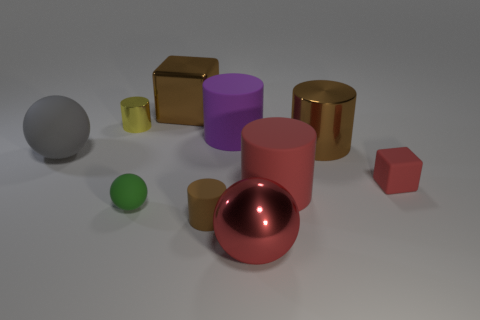There is a red thing that is the same shape as the gray object; what size is it?
Offer a terse response. Large. There is a shiny thing that is the same shape as the tiny red rubber object; what is its color?
Offer a terse response. Brown. What color is the matte ball that is the same size as the yellow shiny cylinder?
Provide a short and direct response. Green. What number of large things are green balls or yellow rubber things?
Your response must be concise. 0. What material is the big object that is both in front of the yellow metal object and on the left side of the purple cylinder?
Offer a terse response. Rubber. There is a large red object that is in front of the small green object; does it have the same shape as the big matte object left of the tiny green thing?
Ensure brevity in your answer.  Yes. There is a shiny object that is the same color as the tiny cube; what shape is it?
Your answer should be compact. Sphere. What number of objects are either large balls right of the small ball or big brown things?
Provide a short and direct response. 3. Do the gray object and the red metal thing have the same size?
Offer a very short reply. Yes. There is a big rubber cylinder that is in front of the big purple rubber cylinder; what color is it?
Your response must be concise. Red. 